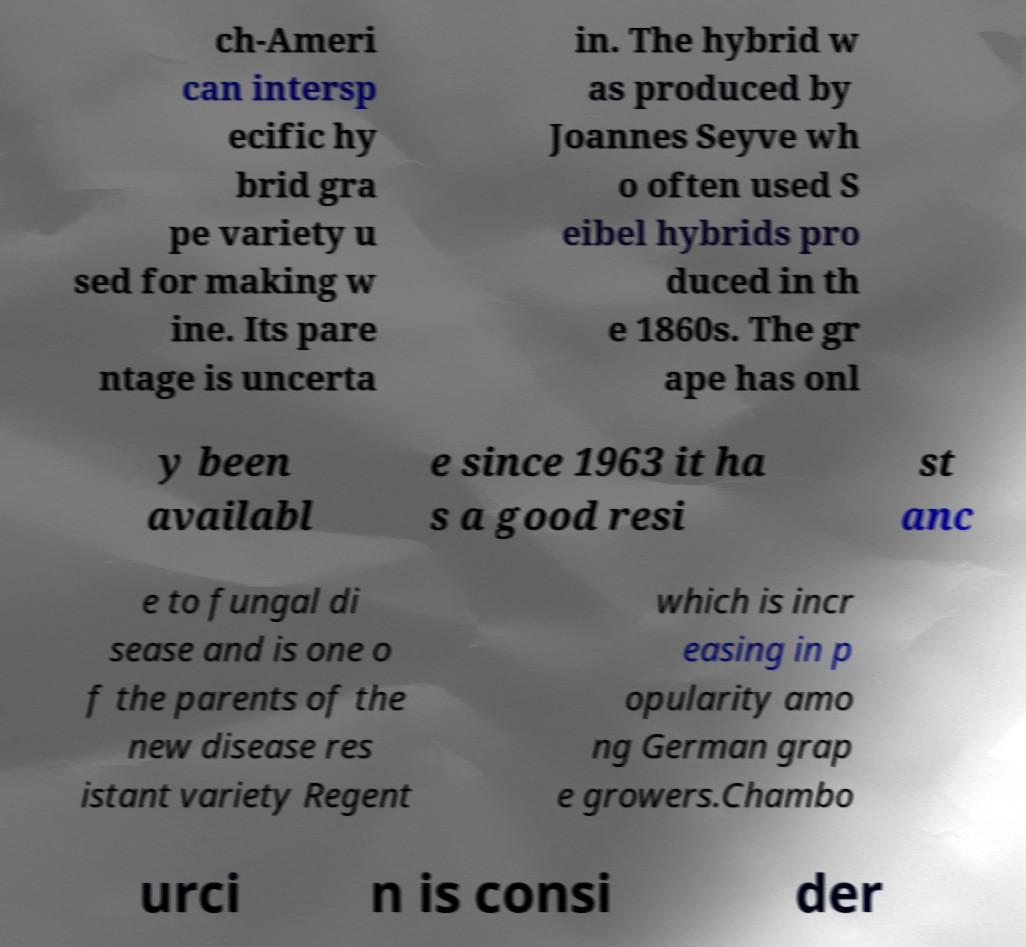There's text embedded in this image that I need extracted. Can you transcribe it verbatim? ch-Ameri can intersp ecific hy brid gra pe variety u sed for making w ine. Its pare ntage is uncerta in. The hybrid w as produced by Joannes Seyve wh o often used S eibel hybrids pro duced in th e 1860s. The gr ape has onl y been availabl e since 1963 it ha s a good resi st anc e to fungal di sease and is one o f the parents of the new disease res istant variety Regent which is incr easing in p opularity amo ng German grap e growers.Chambo urci n is consi der 